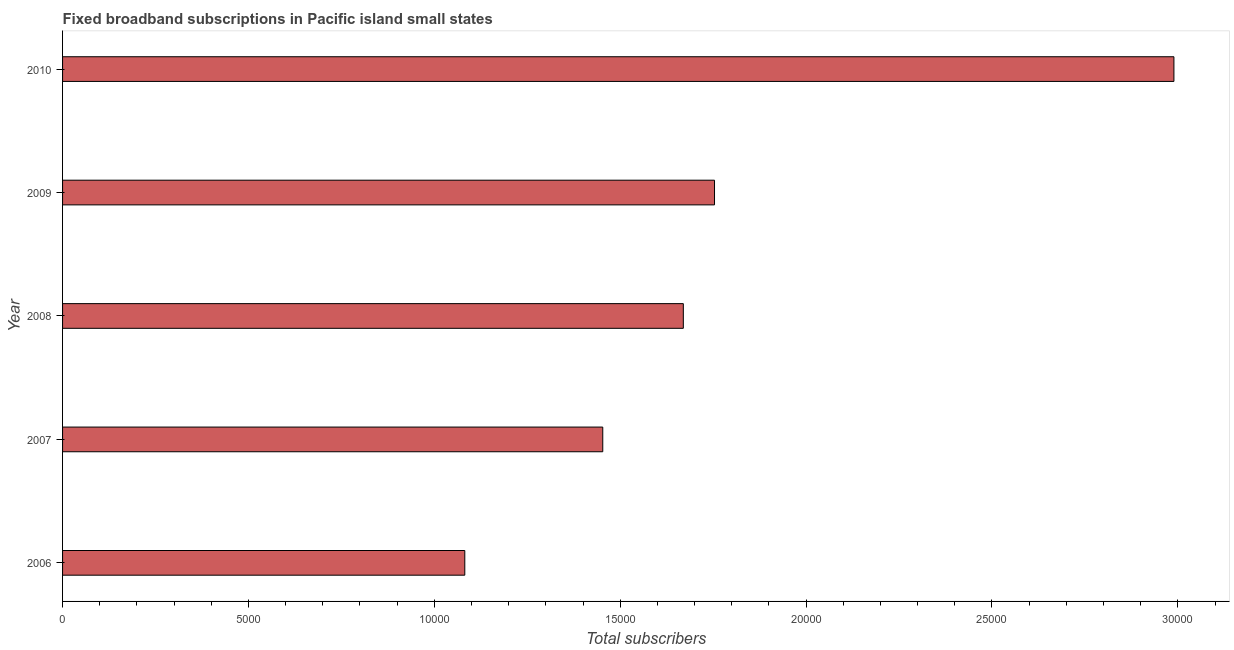What is the title of the graph?
Your answer should be compact. Fixed broadband subscriptions in Pacific island small states. What is the label or title of the X-axis?
Your response must be concise. Total subscribers. What is the label or title of the Y-axis?
Ensure brevity in your answer.  Year. What is the total number of fixed broadband subscriptions in 2009?
Provide a short and direct response. 1.75e+04. Across all years, what is the maximum total number of fixed broadband subscriptions?
Give a very brief answer. 2.99e+04. Across all years, what is the minimum total number of fixed broadband subscriptions?
Offer a very short reply. 1.08e+04. In which year was the total number of fixed broadband subscriptions minimum?
Offer a terse response. 2006. What is the sum of the total number of fixed broadband subscriptions?
Make the answer very short. 8.95e+04. What is the difference between the total number of fixed broadband subscriptions in 2006 and 2009?
Give a very brief answer. -6717. What is the average total number of fixed broadband subscriptions per year?
Offer a terse response. 1.79e+04. What is the median total number of fixed broadband subscriptions?
Give a very brief answer. 1.67e+04. What is the ratio of the total number of fixed broadband subscriptions in 2006 to that in 2009?
Your answer should be very brief. 0.62. Is the total number of fixed broadband subscriptions in 2006 less than that in 2009?
Make the answer very short. Yes. What is the difference between the highest and the second highest total number of fixed broadband subscriptions?
Make the answer very short. 1.24e+04. What is the difference between the highest and the lowest total number of fixed broadband subscriptions?
Give a very brief answer. 1.91e+04. Are all the bars in the graph horizontal?
Your answer should be compact. Yes. How many years are there in the graph?
Your answer should be very brief. 5. What is the Total subscribers in 2006?
Your answer should be compact. 1.08e+04. What is the Total subscribers in 2007?
Make the answer very short. 1.45e+04. What is the Total subscribers of 2008?
Give a very brief answer. 1.67e+04. What is the Total subscribers in 2009?
Offer a very short reply. 1.75e+04. What is the Total subscribers in 2010?
Your answer should be compact. 2.99e+04. What is the difference between the Total subscribers in 2006 and 2007?
Offer a terse response. -3711. What is the difference between the Total subscribers in 2006 and 2008?
Ensure brevity in your answer.  -5878. What is the difference between the Total subscribers in 2006 and 2009?
Ensure brevity in your answer.  -6717. What is the difference between the Total subscribers in 2006 and 2010?
Your response must be concise. -1.91e+04. What is the difference between the Total subscribers in 2007 and 2008?
Keep it short and to the point. -2167. What is the difference between the Total subscribers in 2007 and 2009?
Your response must be concise. -3006. What is the difference between the Total subscribers in 2007 and 2010?
Provide a short and direct response. -1.54e+04. What is the difference between the Total subscribers in 2008 and 2009?
Offer a terse response. -839. What is the difference between the Total subscribers in 2008 and 2010?
Provide a short and direct response. -1.32e+04. What is the difference between the Total subscribers in 2009 and 2010?
Your answer should be compact. -1.24e+04. What is the ratio of the Total subscribers in 2006 to that in 2007?
Ensure brevity in your answer.  0.74. What is the ratio of the Total subscribers in 2006 to that in 2008?
Offer a very short reply. 0.65. What is the ratio of the Total subscribers in 2006 to that in 2009?
Ensure brevity in your answer.  0.62. What is the ratio of the Total subscribers in 2006 to that in 2010?
Offer a terse response. 0.36. What is the ratio of the Total subscribers in 2007 to that in 2008?
Provide a succinct answer. 0.87. What is the ratio of the Total subscribers in 2007 to that in 2009?
Offer a terse response. 0.83. What is the ratio of the Total subscribers in 2007 to that in 2010?
Offer a terse response. 0.49. What is the ratio of the Total subscribers in 2008 to that in 2009?
Provide a succinct answer. 0.95. What is the ratio of the Total subscribers in 2008 to that in 2010?
Your answer should be compact. 0.56. What is the ratio of the Total subscribers in 2009 to that in 2010?
Offer a terse response. 0.59. 